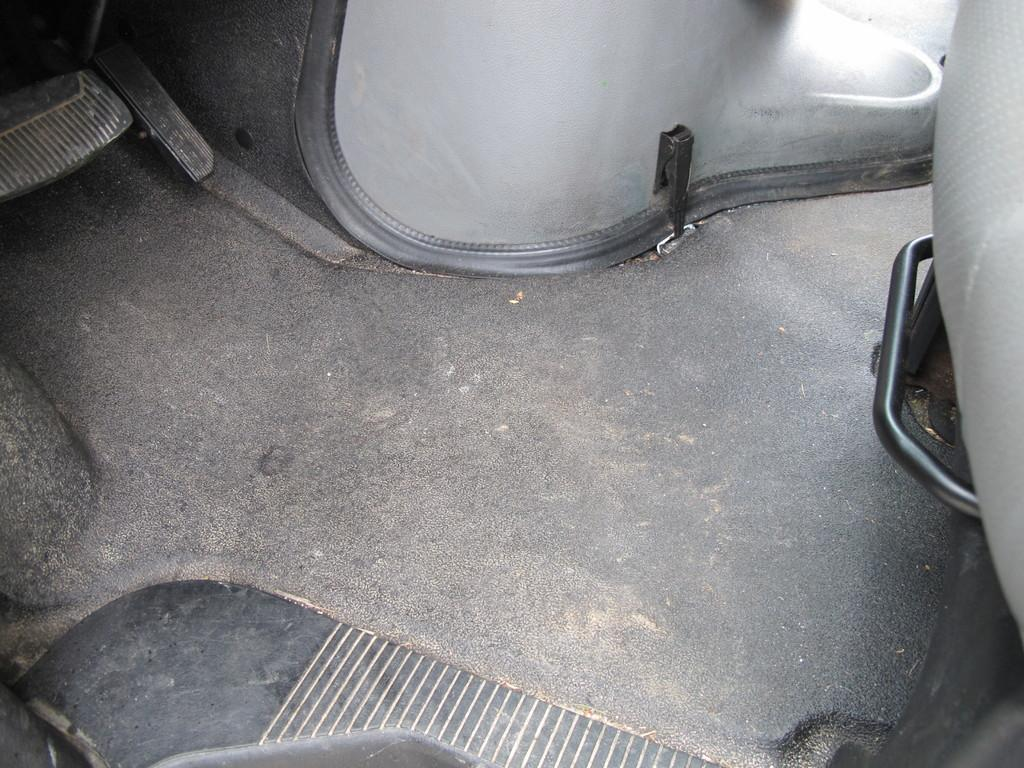What is the main subject of the image? The main subject of the image is a vehicle. What can be seen inside the vehicle? There are objects inside the vehicle in the image. What type of jewel can be seen on the brick wall in the image? There is no brick wall or jewel present in the image; it only features a vehicle with objects inside. 